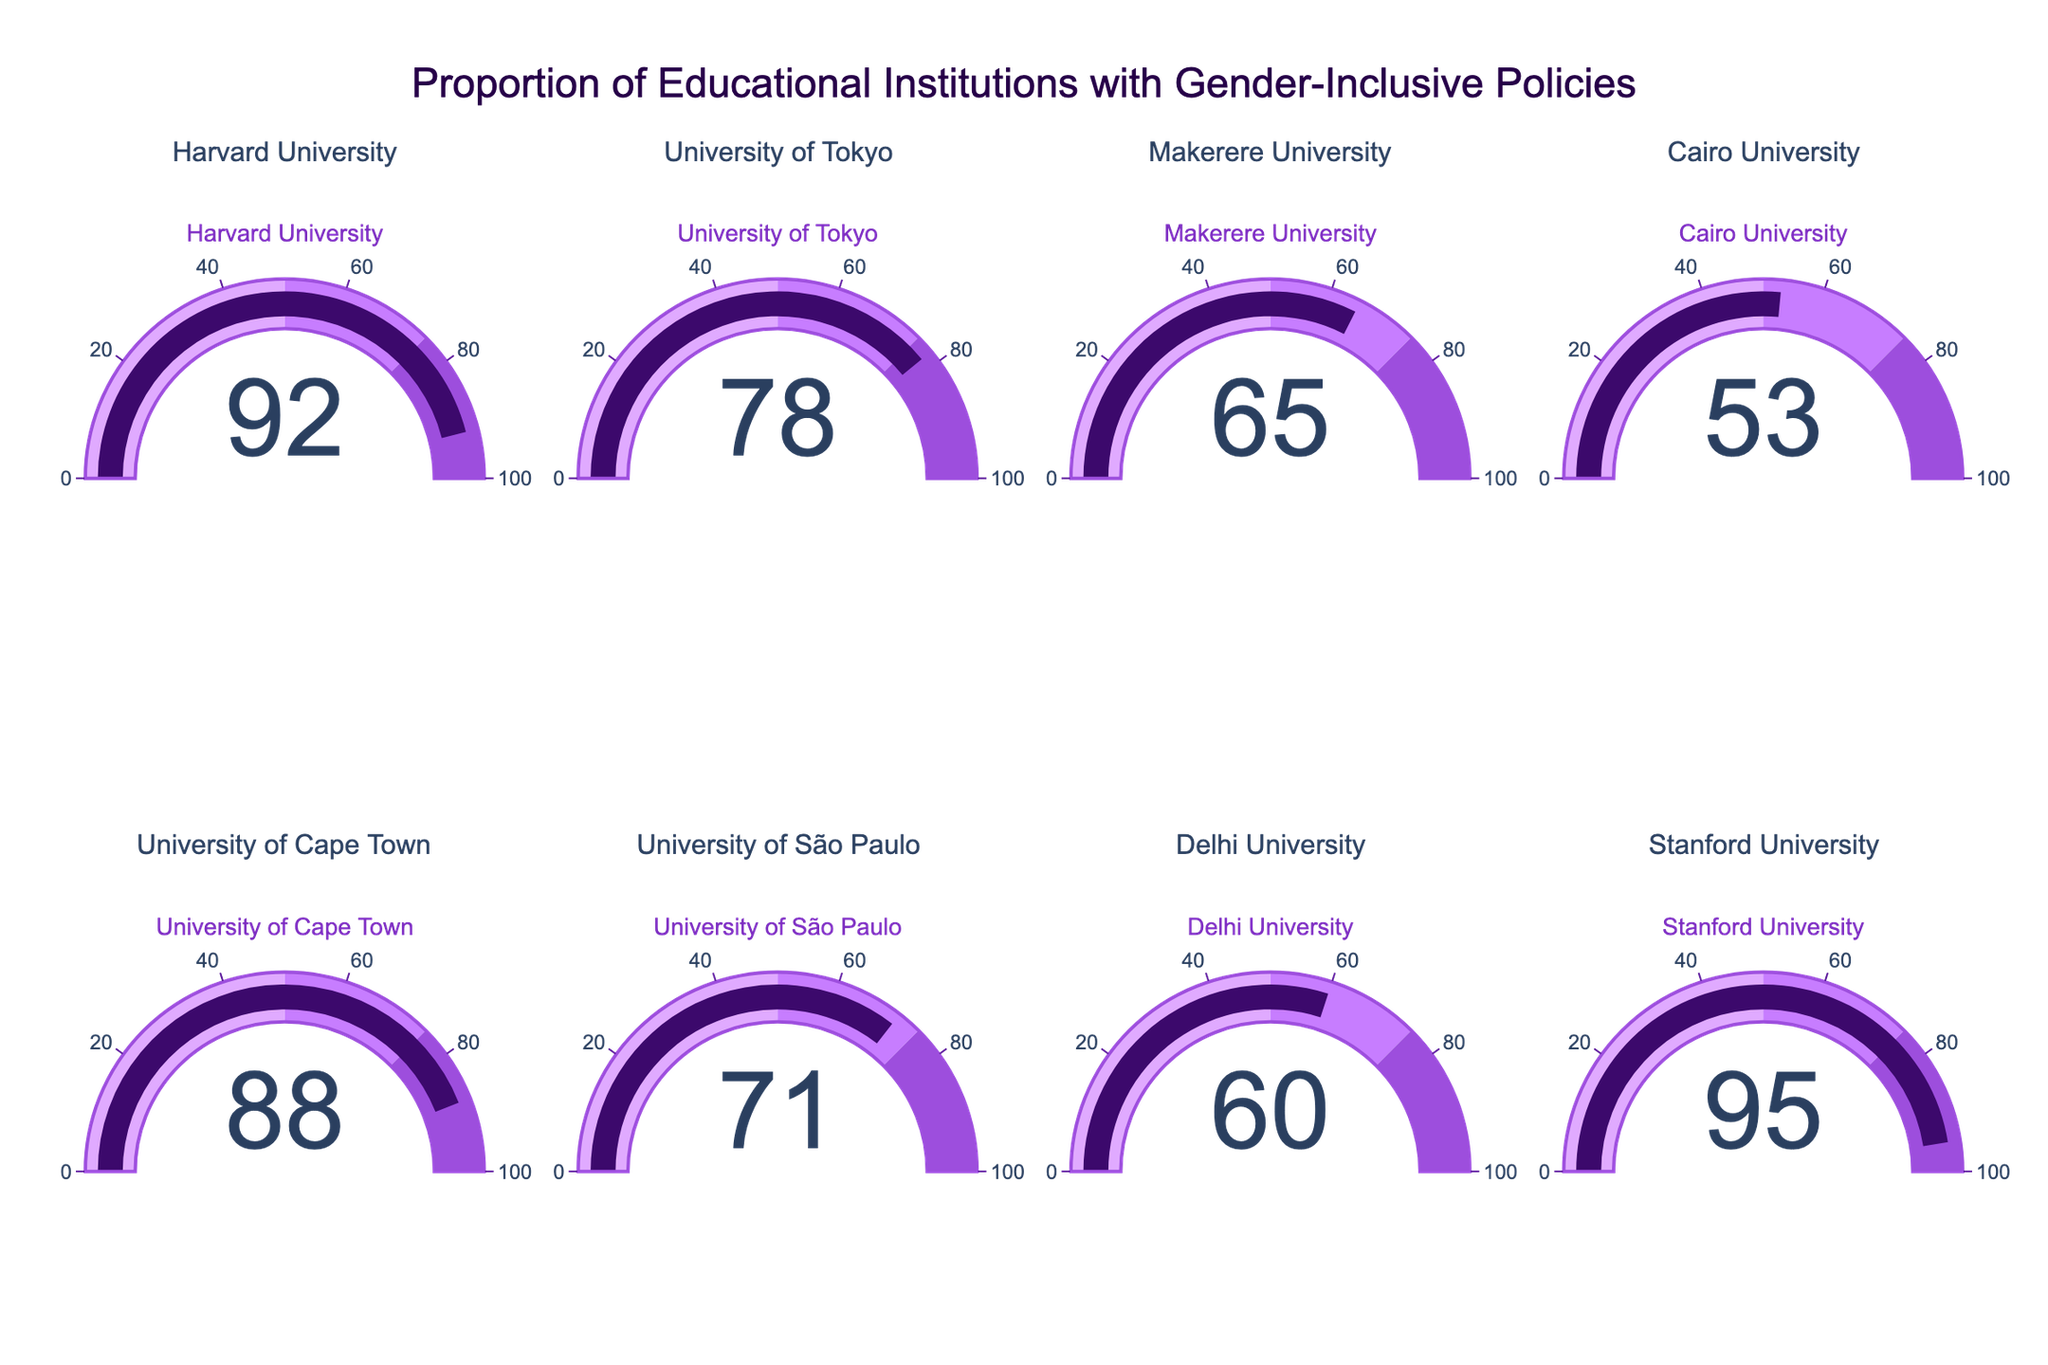what's the title of the figure? The title is usually displayed at the top of the figure. Looking at the figure, the title is "Proportion of Educational Institutions with Gender-Inclusive Policies".
Answer: Proportion of Educational Institutions with Gender-Inclusive Policies how many educational institutions are displayed in the figure? To find the number of educational institutions, count the number of gauges in the figure. There are 8 gauges, each representing a different institution.
Answer: 8 which institution has the highest proportion of gender-inclusive policies? Look for the gauge with the highest percentage value. The highest value, 95%, appears in the gauge for Stanford University.
Answer: Stanford University which institution has the lowest proportion of gender-inclusive policies? Find the gauge with the lowest percentage value. The lowest value, 53%, appears in the gauge for Cairo University.
Answer: Cairo University what is the average proportion of gender-inclusive policies across all institutions? Add the percentages for all the institutions and divide by the number of institutions: (92 + 78 + 65 + 53 + 88 + 71 + 60 + 95) / 8 = 75.25%.
Answer: 75.25% how many institutions have a proportion of gender-inclusive policies above 75%? Count the number of gauges with values greater than 75%. The institutions are Harvard University (92), University of Tokyo (78), University of Cape Town (88), and Stanford University (95). There are 4 of them.
Answer: 4 which institutions have a proportion of gender-inclusive policies between 60% and 80%? Identify gauges with values between 60% and 80%. The institutions are University of Tokyo (78), Makerere University (65), University of São Paulo (71), and Delhi University (60).
Answer: University of Tokyo, Makerere University, University of São Paulo, Delhi University which institution falls closest to the midpoint of the percentage scale (50%)? Find the institution with a value closest to 50%. The institution closest to 50% is Cairo University with 53%.
Answer: Cairo University what is the proportion difference in gender-inclusive policies between Harvard University and Delhi University? Subtract the percentage of Delhi University from Harvard University: 92% - 60% = 32%.
Answer: 32% which institutions are represented by the gauges in the second row of the figure? Identify the institutions listed starting from the fifth institution in the order provided: University of Cape Town, University of São Paulo, Delhi University, and Stanford University.
Answer: University of Cape Town, University of São Paulo, Delhi University, Stanford University 